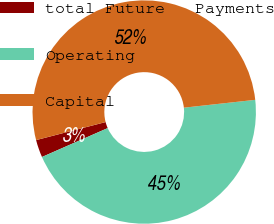<chart> <loc_0><loc_0><loc_500><loc_500><pie_chart><fcel>total Future   Payments<fcel>Operating<fcel>Capital<nl><fcel>2.55%<fcel>45.15%<fcel>52.3%<nl></chart> 